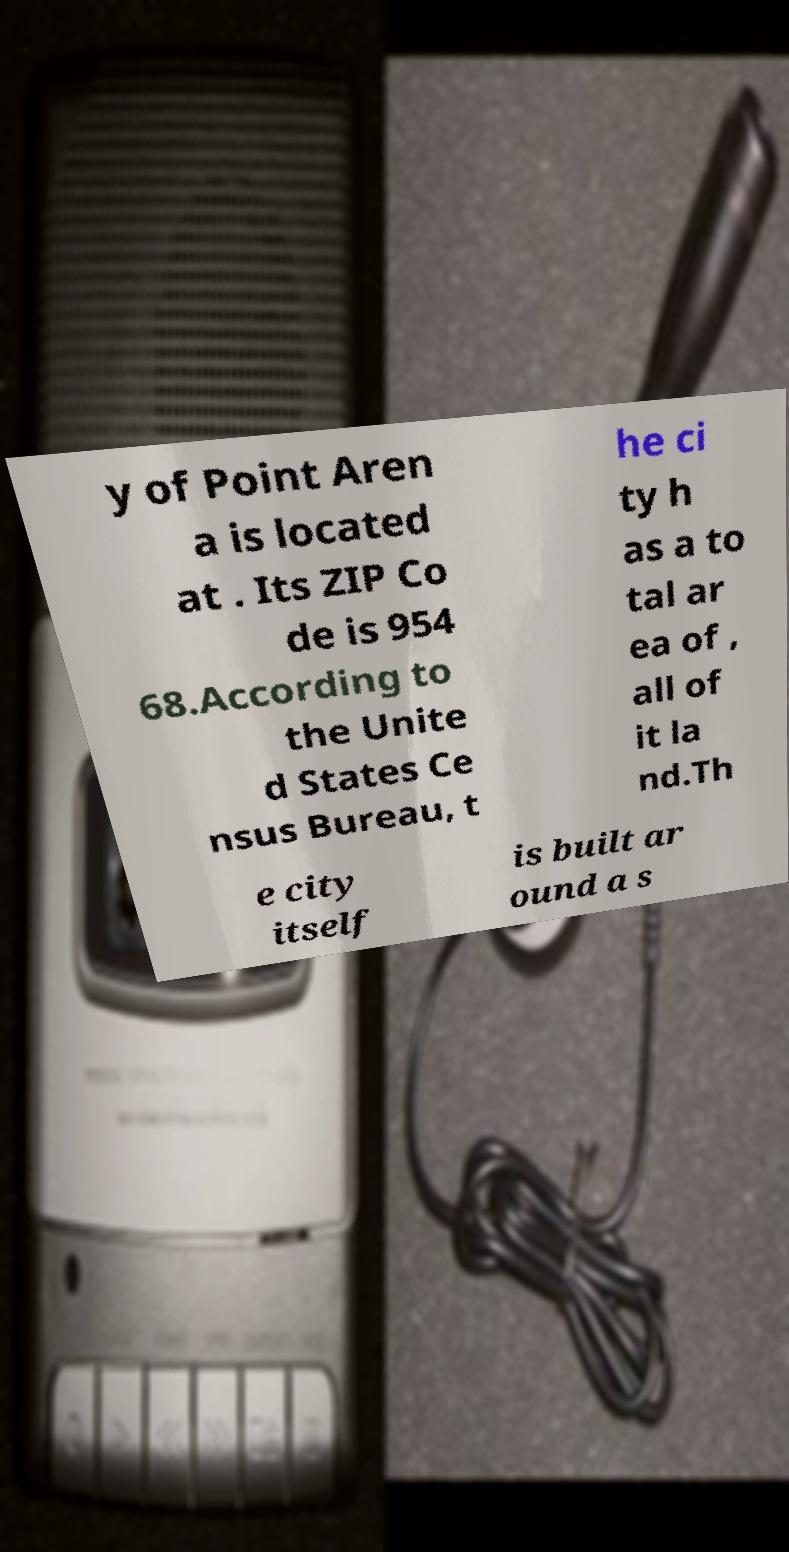What messages or text are displayed in this image? I need them in a readable, typed format. y of Point Aren a is located at . Its ZIP Co de is 954 68.According to the Unite d States Ce nsus Bureau, t he ci ty h as a to tal ar ea of , all of it la nd.Th e city itself is built ar ound a s 